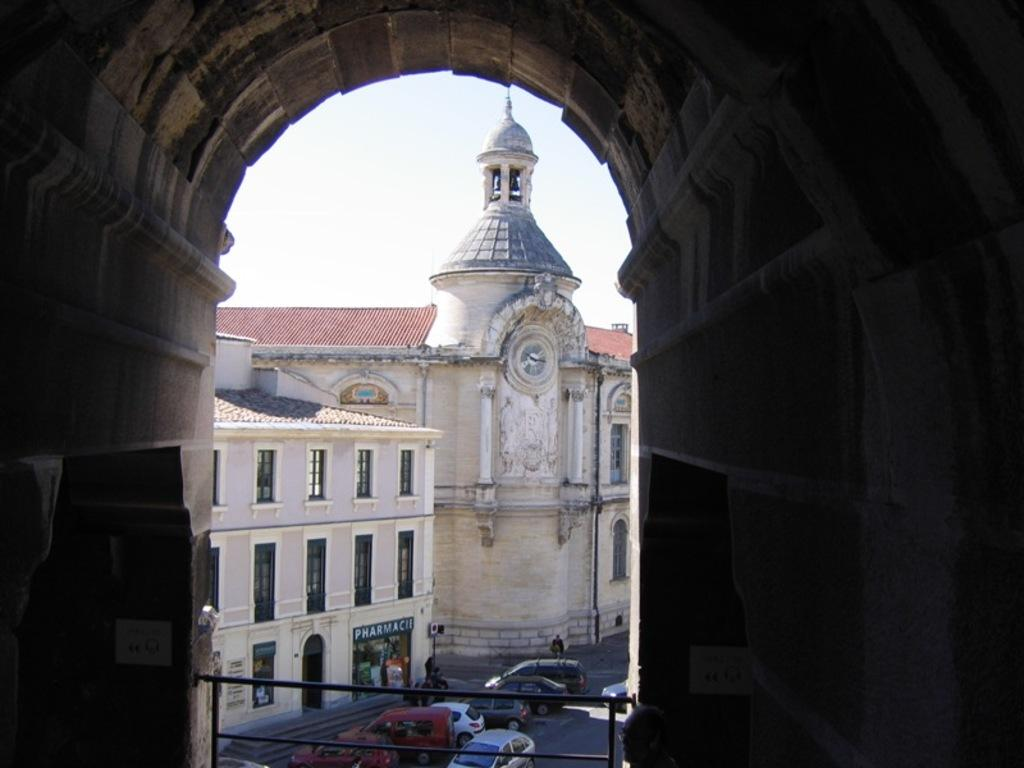What type of structures are present in the image? There are buildings in the image. What architectural feature can be seen on the buildings? There are windows in the image. What type of vehicles are visible in the image? There are cars in the image. What time-telling device is present in the image? There is a clock in the image. What is visible in the sky in the image? The sky is visible in the image. What type of rake is being used to clean the day in the image? There is no rake or reference to cleaning a day present in the image. What type of account is being managed in the image? There is no mention of an account or any financial activity in the image. 